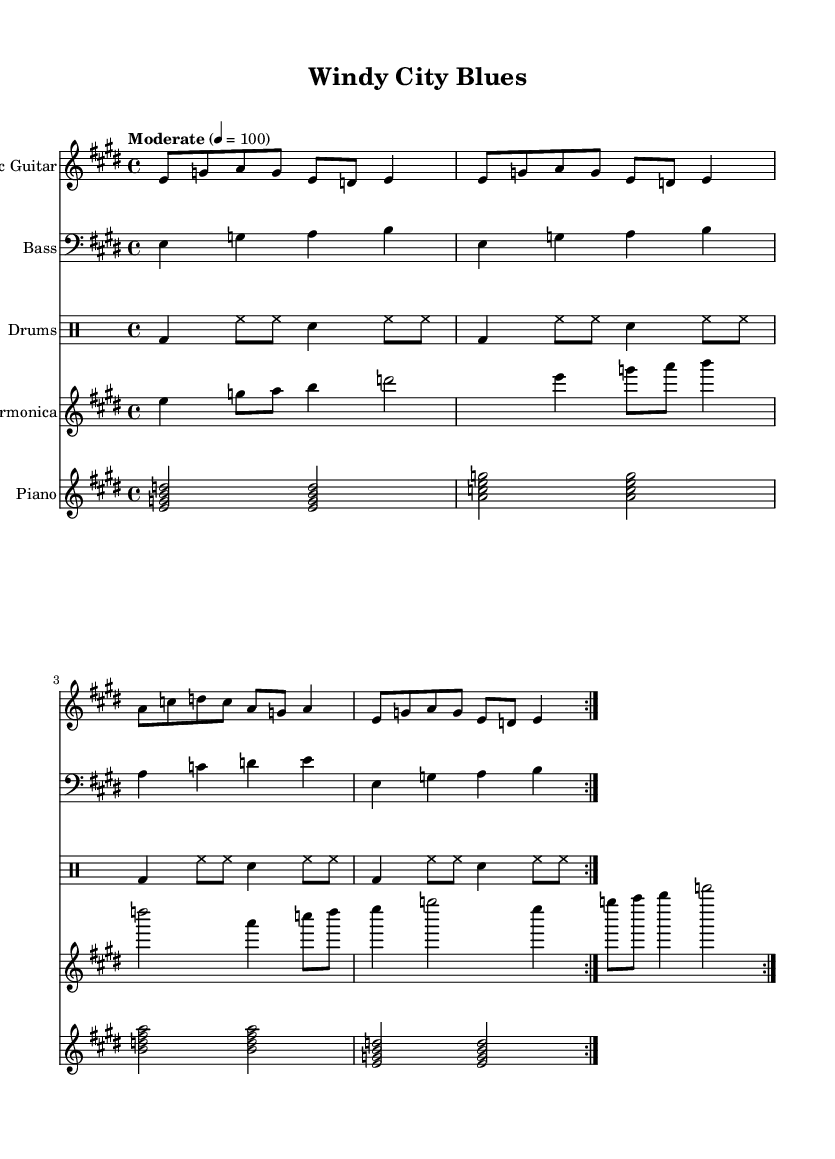What is the key signature of this music? The key signature can be determined by looking for sharps or flats at the beginning of the staff. In this case, it shows four sharps, indicating it is in E major.
Answer: E major What is the time signature of this music? The time signature appears at the beginning of the staff and is indicated by the numbers on the left side. Here, it shows 4 over 4, which means there are four beats in each measure.
Answer: 4/4 What is the tempo marking for this piece? The tempo marking is typically indicated above the staff, and here it states "Moderate" with a beat set at 100, which shows how fast the music should be played.
Answer: Moderate 4 = 100 How many measures does the piece repeat? We can identify repetitions by looking for volta signs in the music notation; both the electric guitar and harmonica parts show a repeat with two volta signs. Therefore, it repeats twice.
Answer: 2 What instruments are included in this score? By examining the part names on the left side of the staff, we can identify the instruments: Electric Guitar, Bass, Drums, Harmonica, and Piano, comprising all the sections of this piece.
Answer: Electric Guitar, Bass, Drums, Harmonica, Piano What is the harmonic structure of the bass guitar part? Analyzing the bass guitar part, it mainly outlines a progression from E to A, which indicates the chord changes typical of the blues style, establishing a foundation of the song’s harmony.
Answer: E to A What makes this piece characteristic of Chicago electric blues? The inclusion of instruments such as the electric guitar, harmonica, and a steady drumbeat establishes the sound of Chicago electric blues, and the specific riffs and call-and-response nature are typical of this genre.
Answer: Electric guitar, harmonica, drumbeat 